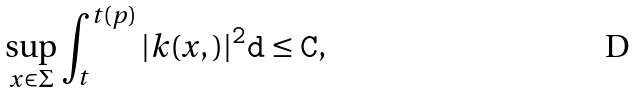<formula> <loc_0><loc_0><loc_500><loc_500>\sup _ { x \in \Sigma } \int _ { t } ^ { t ( p ) } | k ( x , \tt ) | ^ { 2 } d \tt \leq C ,</formula> 